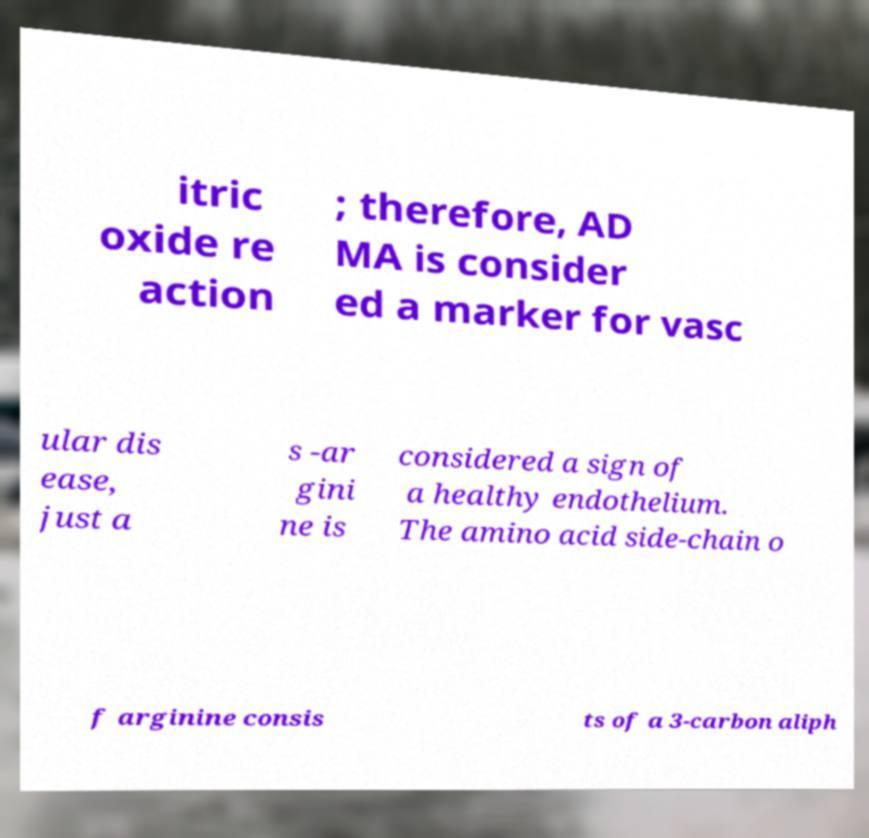Please identify and transcribe the text found in this image. itric oxide re action ; therefore, AD MA is consider ed a marker for vasc ular dis ease, just a s -ar gini ne is considered a sign of a healthy endothelium. The amino acid side-chain o f arginine consis ts of a 3-carbon aliph 